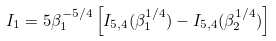<formula> <loc_0><loc_0><loc_500><loc_500>I _ { 1 } = 5 \beta _ { 1 } ^ { - 5 / 4 } \left [ I _ { 5 , 4 } ( \beta _ { 1 } ^ { 1 / 4 } ) - I _ { 5 , 4 } ( \beta _ { 2 } ^ { 1 / 4 } ) \right ]</formula> 